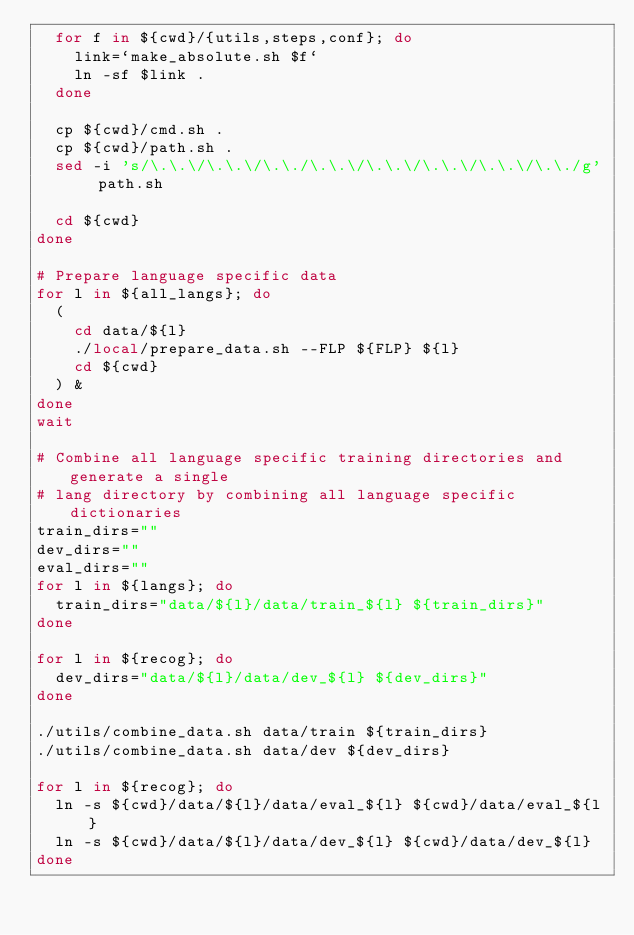<code> <loc_0><loc_0><loc_500><loc_500><_Bash_>  for f in ${cwd}/{utils,steps,conf}; do
    link=`make_absolute.sh $f`
    ln -sf $link .
  done

  cp ${cwd}/cmd.sh .
  cp ${cwd}/path.sh .
  sed -i 's/\.\.\/\.\.\/\.\./\.\.\/\.\.\/\.\.\/\.\.\/\.\./g' path.sh
  
  cd ${cwd}
done

# Prepare language specific data
for l in ${all_langs}; do
  (
    cd data/${l}
    ./local/prepare_data.sh --FLP ${FLP} ${l}
    cd ${cwd}
  ) &
done
wait

# Combine all language specific training directories and generate a single
# lang directory by combining all language specific dictionaries
train_dirs=""
dev_dirs=""
eval_dirs=""
for l in ${langs}; do
  train_dirs="data/${l}/data/train_${l} ${train_dirs}"
done

for l in ${recog}; do
  dev_dirs="data/${l}/data/dev_${l} ${dev_dirs}"
done

./utils/combine_data.sh data/train ${train_dirs}
./utils/combine_data.sh data/dev ${dev_dirs}

for l in ${recog}; do
  ln -s ${cwd}/data/${l}/data/eval_${l} ${cwd}/data/eval_${l}
  ln -s ${cwd}/data/${l}/data/dev_${l} ${cwd}/data/dev_${l}
done

</code> 